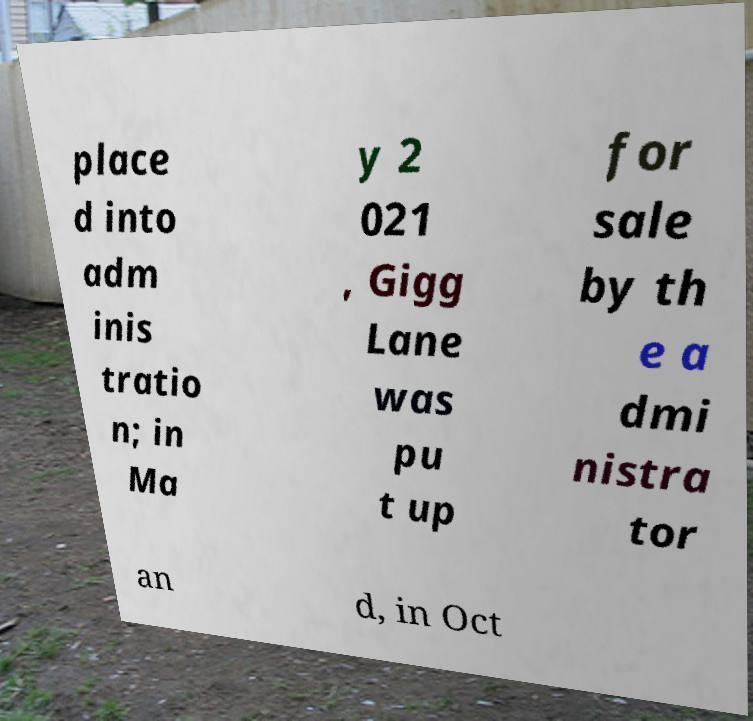I need the written content from this picture converted into text. Can you do that? place d into adm inis tratio n; in Ma y 2 021 , Gigg Lane was pu t up for sale by th e a dmi nistra tor an d, in Oct 